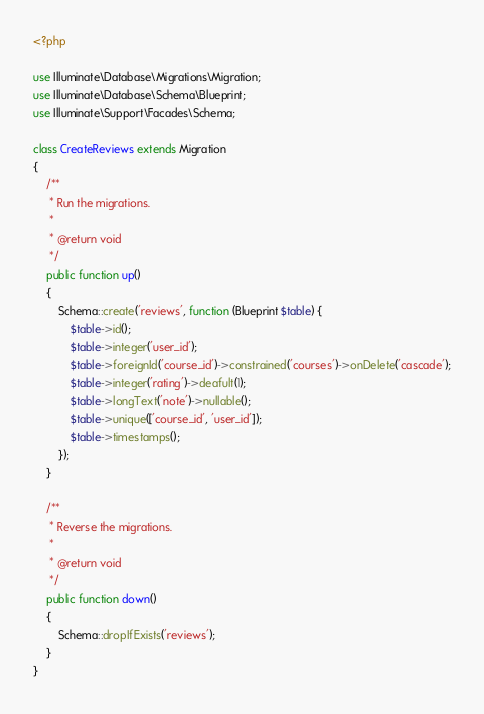<code> <loc_0><loc_0><loc_500><loc_500><_PHP_><?php

use Illuminate\Database\Migrations\Migration;
use Illuminate\Database\Schema\Blueprint;
use Illuminate\Support\Facades\Schema;

class CreateReviews extends Migration
{
    /**
     * Run the migrations.
     *
     * @return void
     */
    public function up()
    {
        Schema::create('reviews', function (Blueprint $table) {
            $table->id();
            $table->integer('user_id');
            $table->foreignId('course_id')->constrained('courses')->onDelete('cascade');
            $table->integer('rating')->deafult(1);
            $table->longText('note')->nullable();
            $table->unique(['course_id', 'user_id']);
            $table->timestamps();
        });
    }

    /**
     * Reverse the migrations.
     *
     * @return void
     */
    public function down()
    {
        Schema::dropIfExists('reviews');
    }
}
</code> 